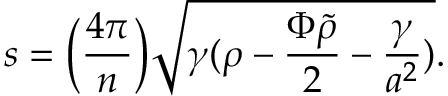Convert formula to latex. <formula><loc_0><loc_0><loc_500><loc_500>s = \left ( { \frac { 4 \pi } { n } } \right ) \sqrt { \gamma ( \rho - { \frac { \Phi \tilde { \rho } } { 2 } } - { \frac { \gamma } { a ^ { 2 } } } ) } .</formula> 